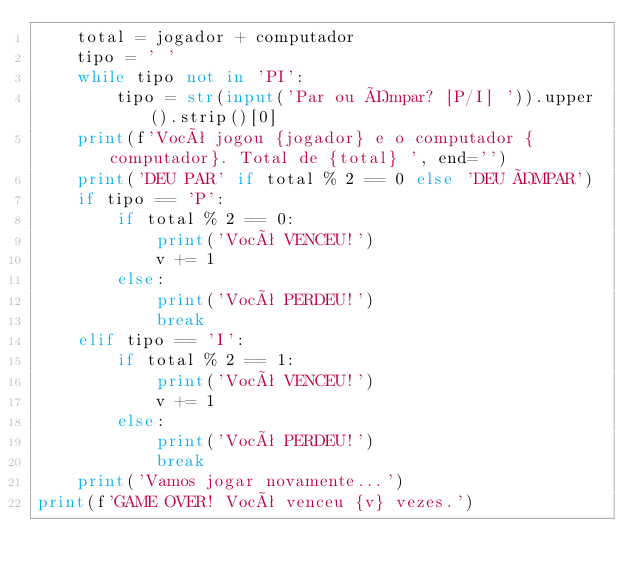Convert code to text. <code><loc_0><loc_0><loc_500><loc_500><_Python_>    total = jogador + computador
    tipo = ' '
    while tipo not in 'PI':
        tipo = str(input('Par ou Ímpar? [P/I] ')).upper().strip()[0]
    print(f'Você jogou {jogador} e o computador {computador}. Total de {total} ', end='')
    print('DEU PAR' if total % 2 == 0 else 'DEU ÍMPAR')
    if tipo == 'P':
        if total % 2 == 0:
            print('Você VENCEU!')
            v += 1
        else:
            print('Você PERDEU!')
            break
    elif tipo == 'I':
        if total % 2 == 1:
            print('Você VENCEU!')
            v += 1
        else:
            print('Você PERDEU!')
            break
    print('Vamos jogar novamente...')
print(f'GAME OVER! Você venceu {v} vezes.')
</code> 